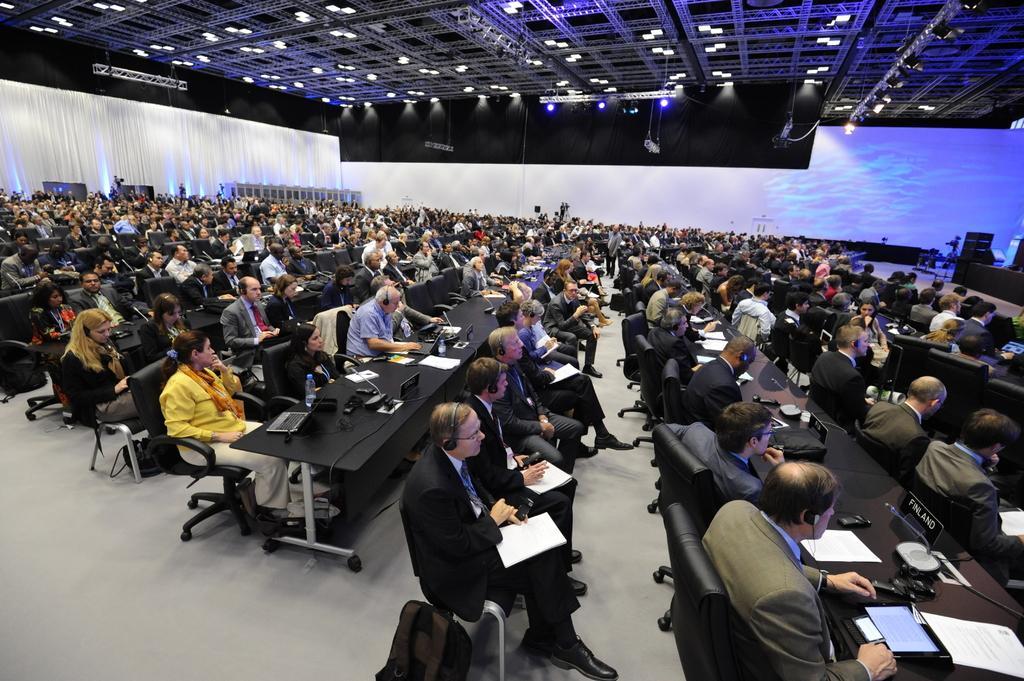In one or two sentences, can you explain what this image depicts? In this image I can see there is a huge room, there are many people sitting on the chairs and they have a few tables in front of them, There are few lights attached to the ceiling. There are laptops, papers and other objects placed on the table. 